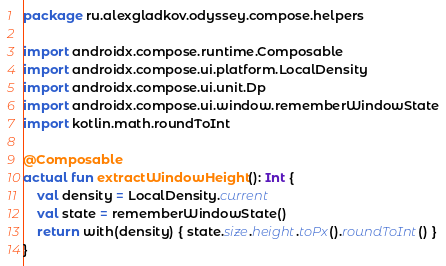Convert code to text. <code><loc_0><loc_0><loc_500><loc_500><_Kotlin_>package ru.alexgladkov.odyssey.compose.helpers

import androidx.compose.runtime.Composable
import androidx.compose.ui.platform.LocalDensity
import androidx.compose.ui.unit.Dp
import androidx.compose.ui.window.rememberWindowState
import kotlin.math.roundToInt

@Composable
actual fun extractWindowHeight(): Int {
    val density = LocalDensity.current
    val state = rememberWindowState()
    return with(density) { state.size.height.toPx().roundToInt() }
}</code> 